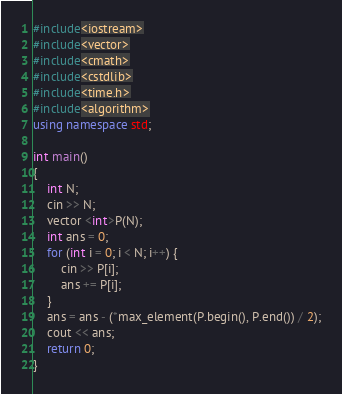Convert code to text. <code><loc_0><loc_0><loc_500><loc_500><_C++_>#include<iostream>
#include<vector>
#include<cmath>
#include<cstdlib>
#include<time.h>
#include<algorithm>
using namespace std;

int main()
{
	int N;
	cin >> N;
	vector <int>P(N);
	int ans = 0;
	for (int i = 0; i < N; i++) {
		cin >> P[i];
		ans += P[i];
	}
	ans = ans - (*max_element(P.begin(), P.end()) / 2);
	cout << ans;
	return 0;
}</code> 